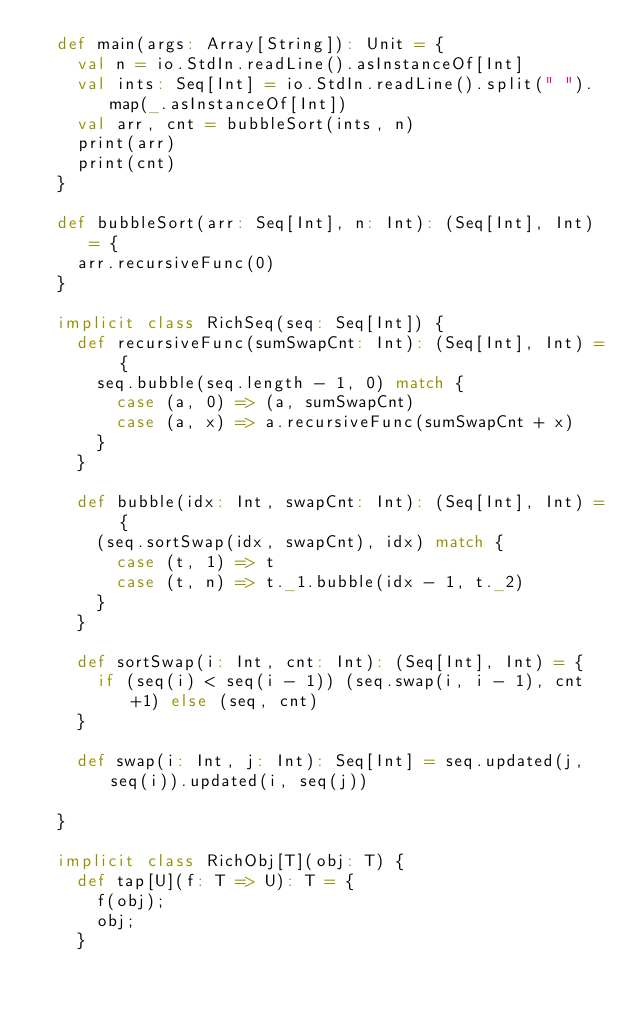Convert code to text. <code><loc_0><loc_0><loc_500><loc_500><_Scala_>  def main(args: Array[String]): Unit = {
    val n = io.StdIn.readLine().asInstanceOf[Int]
    val ints: Seq[Int] = io.StdIn.readLine().split(" ").map(_.asInstanceOf[Int])
    val arr, cnt = bubbleSort(ints, n)
    print(arr)
    print(cnt)
  }

  def bubbleSort(arr: Seq[Int], n: Int): (Seq[Int], Int) = {
    arr.recursiveFunc(0)
  }

  implicit class RichSeq(seq: Seq[Int]) {
    def recursiveFunc(sumSwapCnt: Int): (Seq[Int], Int) = {
      seq.bubble(seq.length - 1, 0) match {
        case (a, 0) => (a, sumSwapCnt)
        case (a, x) => a.recursiveFunc(sumSwapCnt + x)
      }
    }

    def bubble(idx: Int, swapCnt: Int): (Seq[Int], Int) = {
      (seq.sortSwap(idx, swapCnt), idx) match {
        case (t, 1) => t
        case (t, n) => t._1.bubble(idx - 1, t._2)
      }
    }

    def sortSwap(i: Int, cnt: Int): (Seq[Int], Int) = {
      if (seq(i) < seq(i - 1)) (seq.swap(i, i - 1), cnt+1) else (seq, cnt)
    }

    def swap(i: Int, j: Int): Seq[Int] = seq.updated(j, seq(i)).updated(i, seq(j))

  }

  implicit class RichObj[T](obj: T) {
    def tap[U](f: T => U): T = {
      f(obj);
      obj;
    }
</code> 